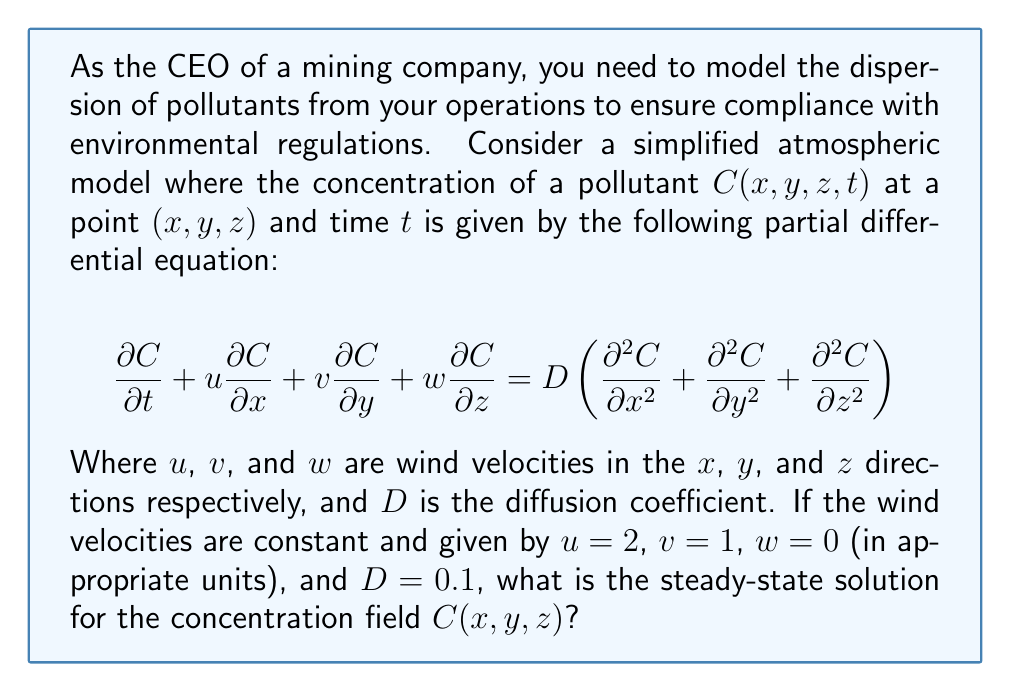Show me your answer to this math problem. To solve this problem, we'll follow these steps:

1) For a steady-state solution, the concentration doesn't change with time, so $\frac{\partial C}{\partial t} = 0$.

2) Substituting the given values and the steady-state condition into the equation:

   $$0 + 2\frac{\partial C}{\partial x} + 1\frac{\partial C}{\partial y} + 0\frac{\partial C}{\partial z} = 0.1\left(\frac{\partial^2 C}{\partial x^2} + \frac{\partial^2 C}{\partial y^2} + \frac{\partial^2 C}{\partial z^2}\right)$$

3) Simplify:

   $$2\frac{\partial C}{\partial x} + \frac{\partial C}{\partial y} = 0.1\left(\frac{\partial^2 C}{\partial x^2} + \frac{\partial^2 C}{\partial y^2} + \frac{\partial^2 C}{\partial z^2}\right)$$

4) The steady-state solution should be of the form:

   $$C(x,y,z) = e^{ax+by+cz}$$

   where $a$, $b$, and $c$ are constants to be determined.

5) Substituting this form into our equation:

   $$2ae^{ax+by+cz} + be^{ax+by+cz} = 0.1(a^2+b^2+c^2)e^{ax+by+cz}$$

6) Dividing both sides by $e^{ax+by+cz}$:

   $$2a + b = 0.1(a^2+b^2+c^2)$$

7) For this to be true for all $x$, $y$, and $z$, we must have:

   $$2a + b = 0$$
   $$a^2 + b^2 + c^2 = 20a$$

8) From the first equation: $b = -2a$

9) Substituting into the second equation:

   $$a^2 + 4a^2 + c^2 = 20a$$
   $$5a^2 + c^2 = 20a$$
   $$5a^2 - 20a + c^2 = 0$$

10) This is satisfied when $a=4$ and $c=0$. Then $b=-8$.

Therefore, the steady-state solution is of the form:

$$C(x,y,z) = Ae^{4x-8y}$$

where $A$ is a constant determined by the boundary conditions.
Answer: $C(x,y,z) = Ae^{4x-8y}$ 